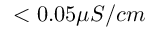Convert formula to latex. <formula><loc_0><loc_0><loc_500><loc_500>< 0 . 0 5 \mu S / c m</formula> 